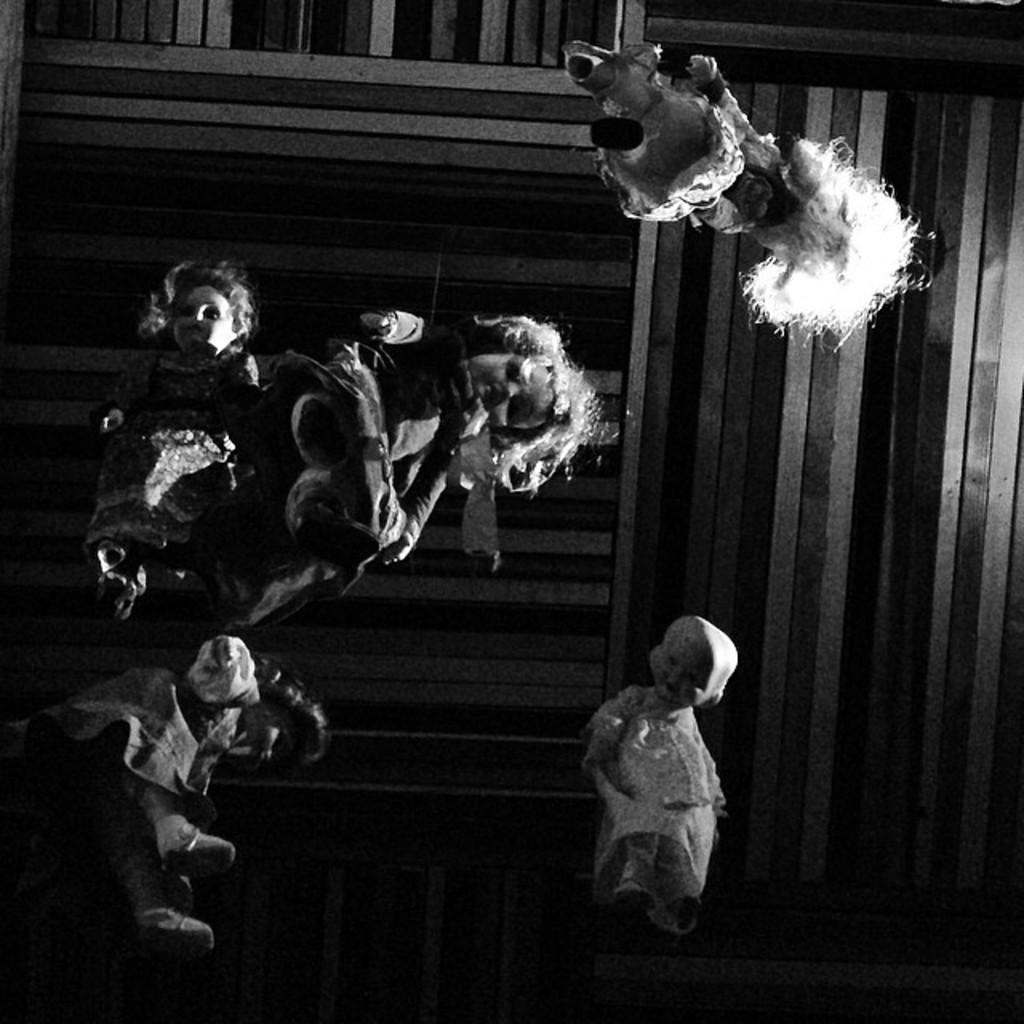What is present above the dolls in the image? There is a ceiling in the image. How are the dolls arranged in the image? Many dolls are hanging from the ceiling. What color scheme is used in the image? The image is black and white. Where is the van parked in the image? There is no van present in the image. What type of flowers can be seen in the garden in the image? There is no garden present in the image. 